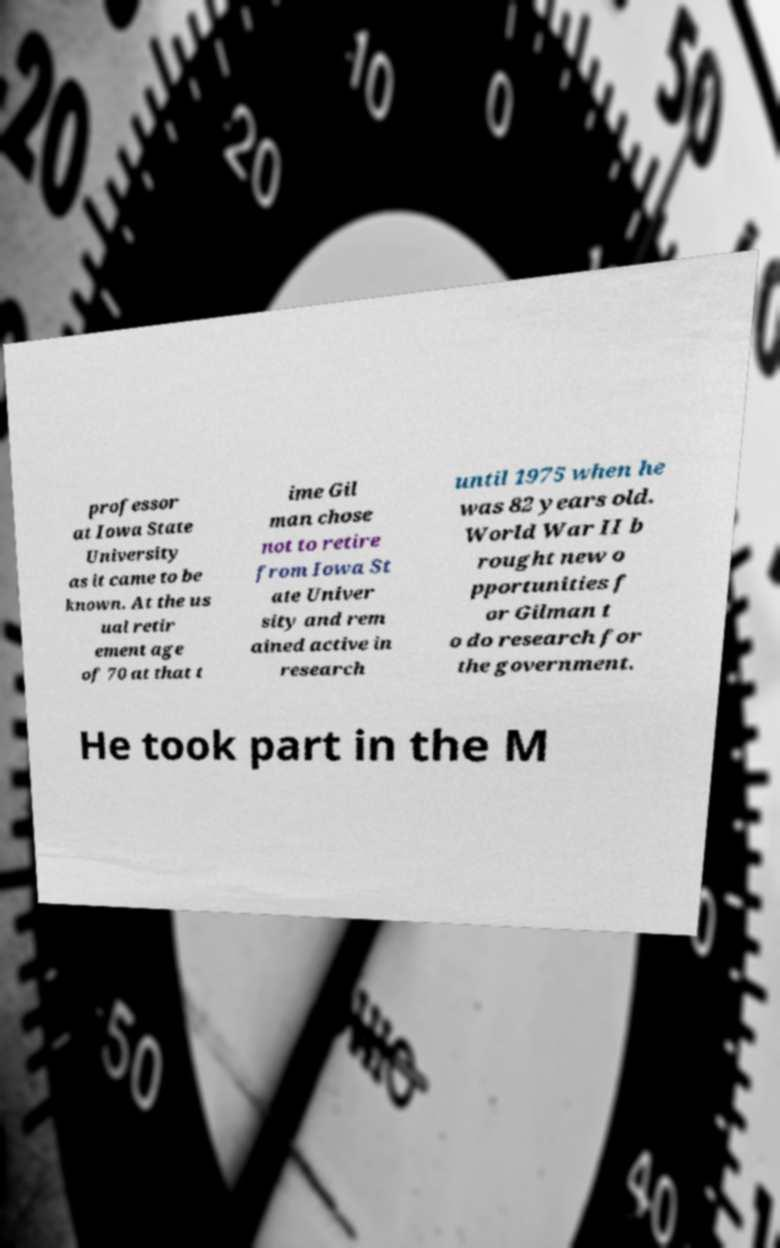I need the written content from this picture converted into text. Can you do that? professor at Iowa State University as it came to be known. At the us ual retir ement age of 70 at that t ime Gil man chose not to retire from Iowa St ate Univer sity and rem ained active in research until 1975 when he was 82 years old. World War II b rought new o pportunities f or Gilman t o do research for the government. He took part in the M 